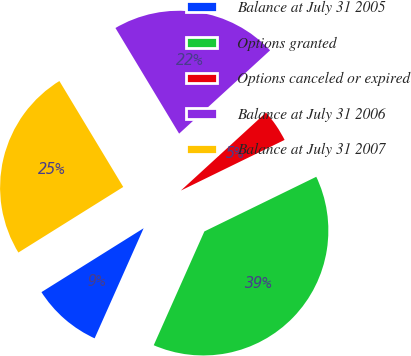Convert chart to OTSL. <chart><loc_0><loc_0><loc_500><loc_500><pie_chart><fcel>Balance at July 31 2005<fcel>Options granted<fcel>Options canceled or expired<fcel>Balance at July 31 2006<fcel>Balance at July 31 2007<nl><fcel>9.44%<fcel>38.89%<fcel>4.57%<fcel>21.83%<fcel>25.26%<nl></chart> 